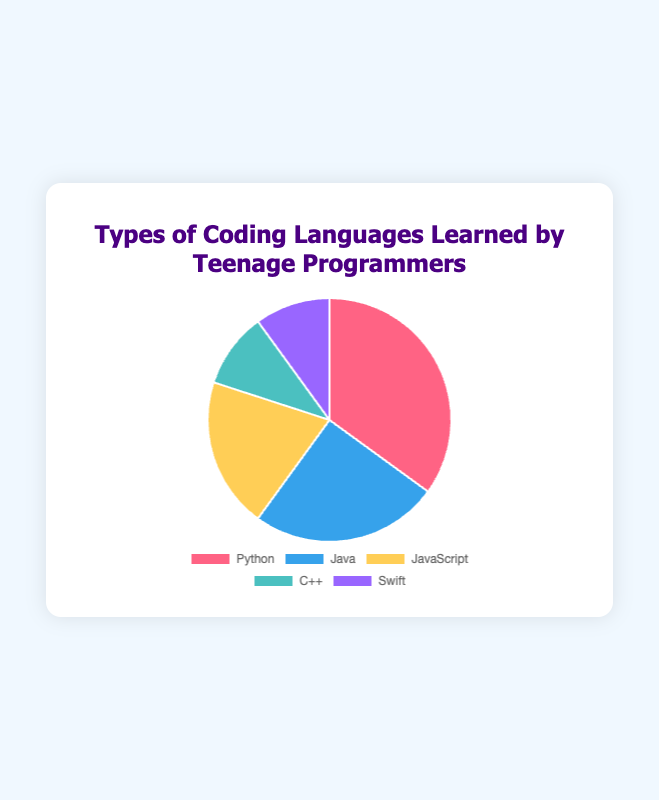Which programming language is the most popular among teenage programmers? Python has the highest percentage at 35% based on the chart.
Answer: Python Which programming language has the smallest share among teenage programmers? Both C++ and Swift have the smallest share, each at 10%.
Answer: C++ and Swift How much more popular is Python than Swift among teenage programmers? The chart shows Python at 35% and Swift at 10%. The difference is 35% - 10% = 25%.
Answer: 25% Compare the popularity of JavaScript and C++. Which one is learned more, and by how much? JavaScript is at 20% while C++ is at 10%. JavaScript is 10% more popular than C++.
Answer: JavaScript by 10% What is the combined percentage of teenagers learning Python and JavaScript? Python is 35% and JavaScript is 20%. The combined percentage is 35% + 20% = 55%.
Answer: 55% Which languages together form exactly half of the teenage programmers' learning preferences? Java and JavaScript together are 25% + 20% = 45%, adding Swift’s 10% total 55%. Python and C++ total 45%. None pairs exactly 50%.
Answer: None If a new survey showed an additional 15% of teenage programmers learning Swift, what would Swift’s new percentage be? Swift is currently at 10%. Adding 15% results in 10% + 15% = 25%.
Answer: 25% What percentage of teenage programmers learn languages other than Python? The total percentage for non-Python languages is 25% (Java) + 20% (JavaScript) + 10% (C++) + 10% (Swift). 25% + 20% + 10% + 10% = 60%.
Answer: 60% Arrange the programming languages from most popular to least popular among teenage programmers. The order from most popular to least popular based on the chart is: Python (35%), Java (25%), JavaScript (20%), C++ (10%), Swift (10%).
Answer: Python, Java, JavaScript, C++, Swift If the percentage of Java learners increased by 5%, how would that affect its rank among the languages? Java would rise from 25%+5%=30%, surpassing JavaScript but still trailing behind Python at 35%, moving Java to the second most popular.
Answer: Java would be 2nd 